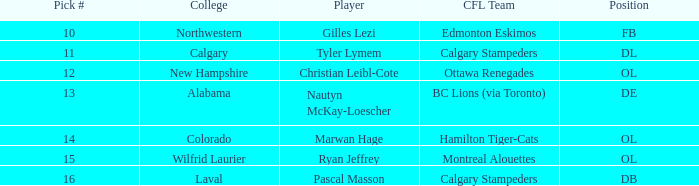From the 2004 cfl draft, which player went to wilfrid laurier university? Ryan Jeffrey. 